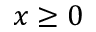<formula> <loc_0><loc_0><loc_500><loc_500>x \geq 0</formula> 